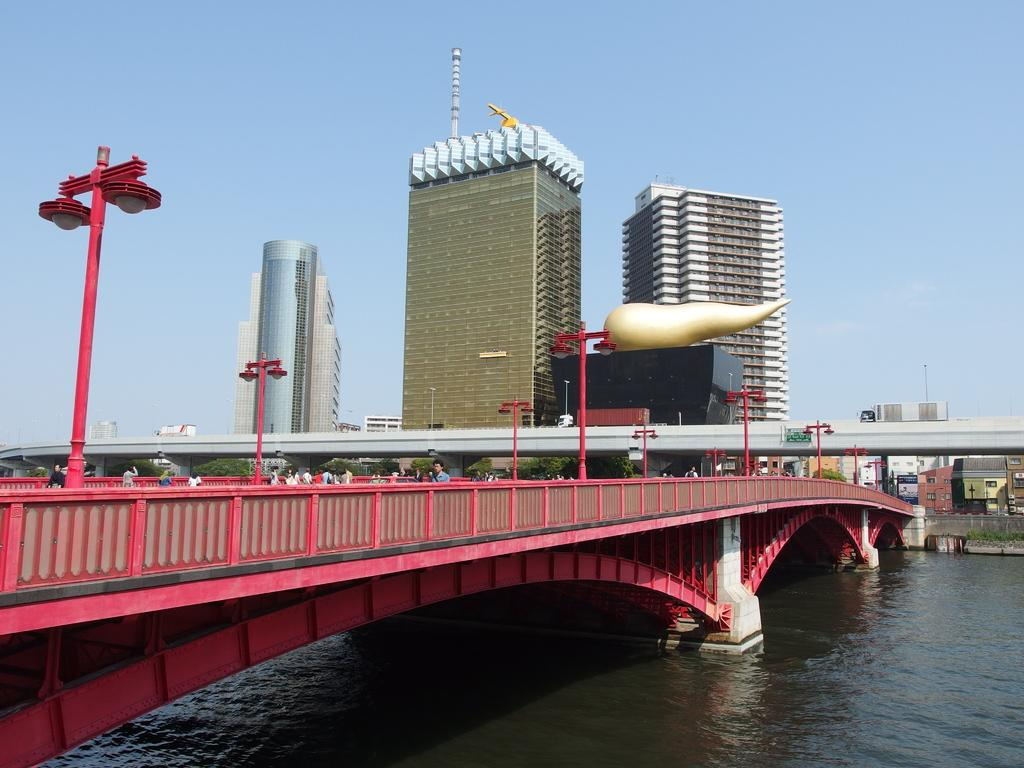What is the color of the bridge in the image? The bridge is red in color. What can be seen on the bridge? There are people on the bridge. What is visible in the background of the image? There are street lights, buildings, the sky, water, and other objects present in the background. What type of plant is growing on the bridge in the image? There are no plants visible on the bridge in the image. What is the weather like in the image? The provided facts do not mention the weather, so it cannot be determined from the image. 